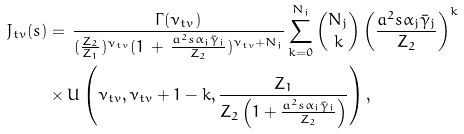Convert formula to latex. <formula><loc_0><loc_0><loc_500><loc_500>{ J _ { t v } } ( s ) & = \, \frac { \Gamma ( \nu _ { t v } ) } { ( \frac { Z _ { 2 } } { Z _ { 1 } } ) ^ { \nu _ { t v } } ( 1 \, + \, \frac { a ^ { 2 } s \alpha _ { j } \bar { \gamma } _ { j } } { Z _ { 2 } } ) ^ { \nu _ { t v } + N _ { j } } } \sum ^ { N _ { j } } _ { k = 0 } \binom { N _ { j } } { k } \left ( \frac { a ^ { 2 } s \alpha _ { j } \bar { \gamma } _ { j } } { Z _ { 2 } } \right ) ^ { k } \\ & \times U \left ( \nu _ { t v } , \nu _ { t v } + 1 - k , \frac { Z _ { 1 } } { Z _ { 2 } \left ( 1 + \frac { a ^ { 2 } s \alpha _ { j } \bar { \gamma } _ { j } } { Z _ { 2 } } \right ) } \right ) ,</formula> 